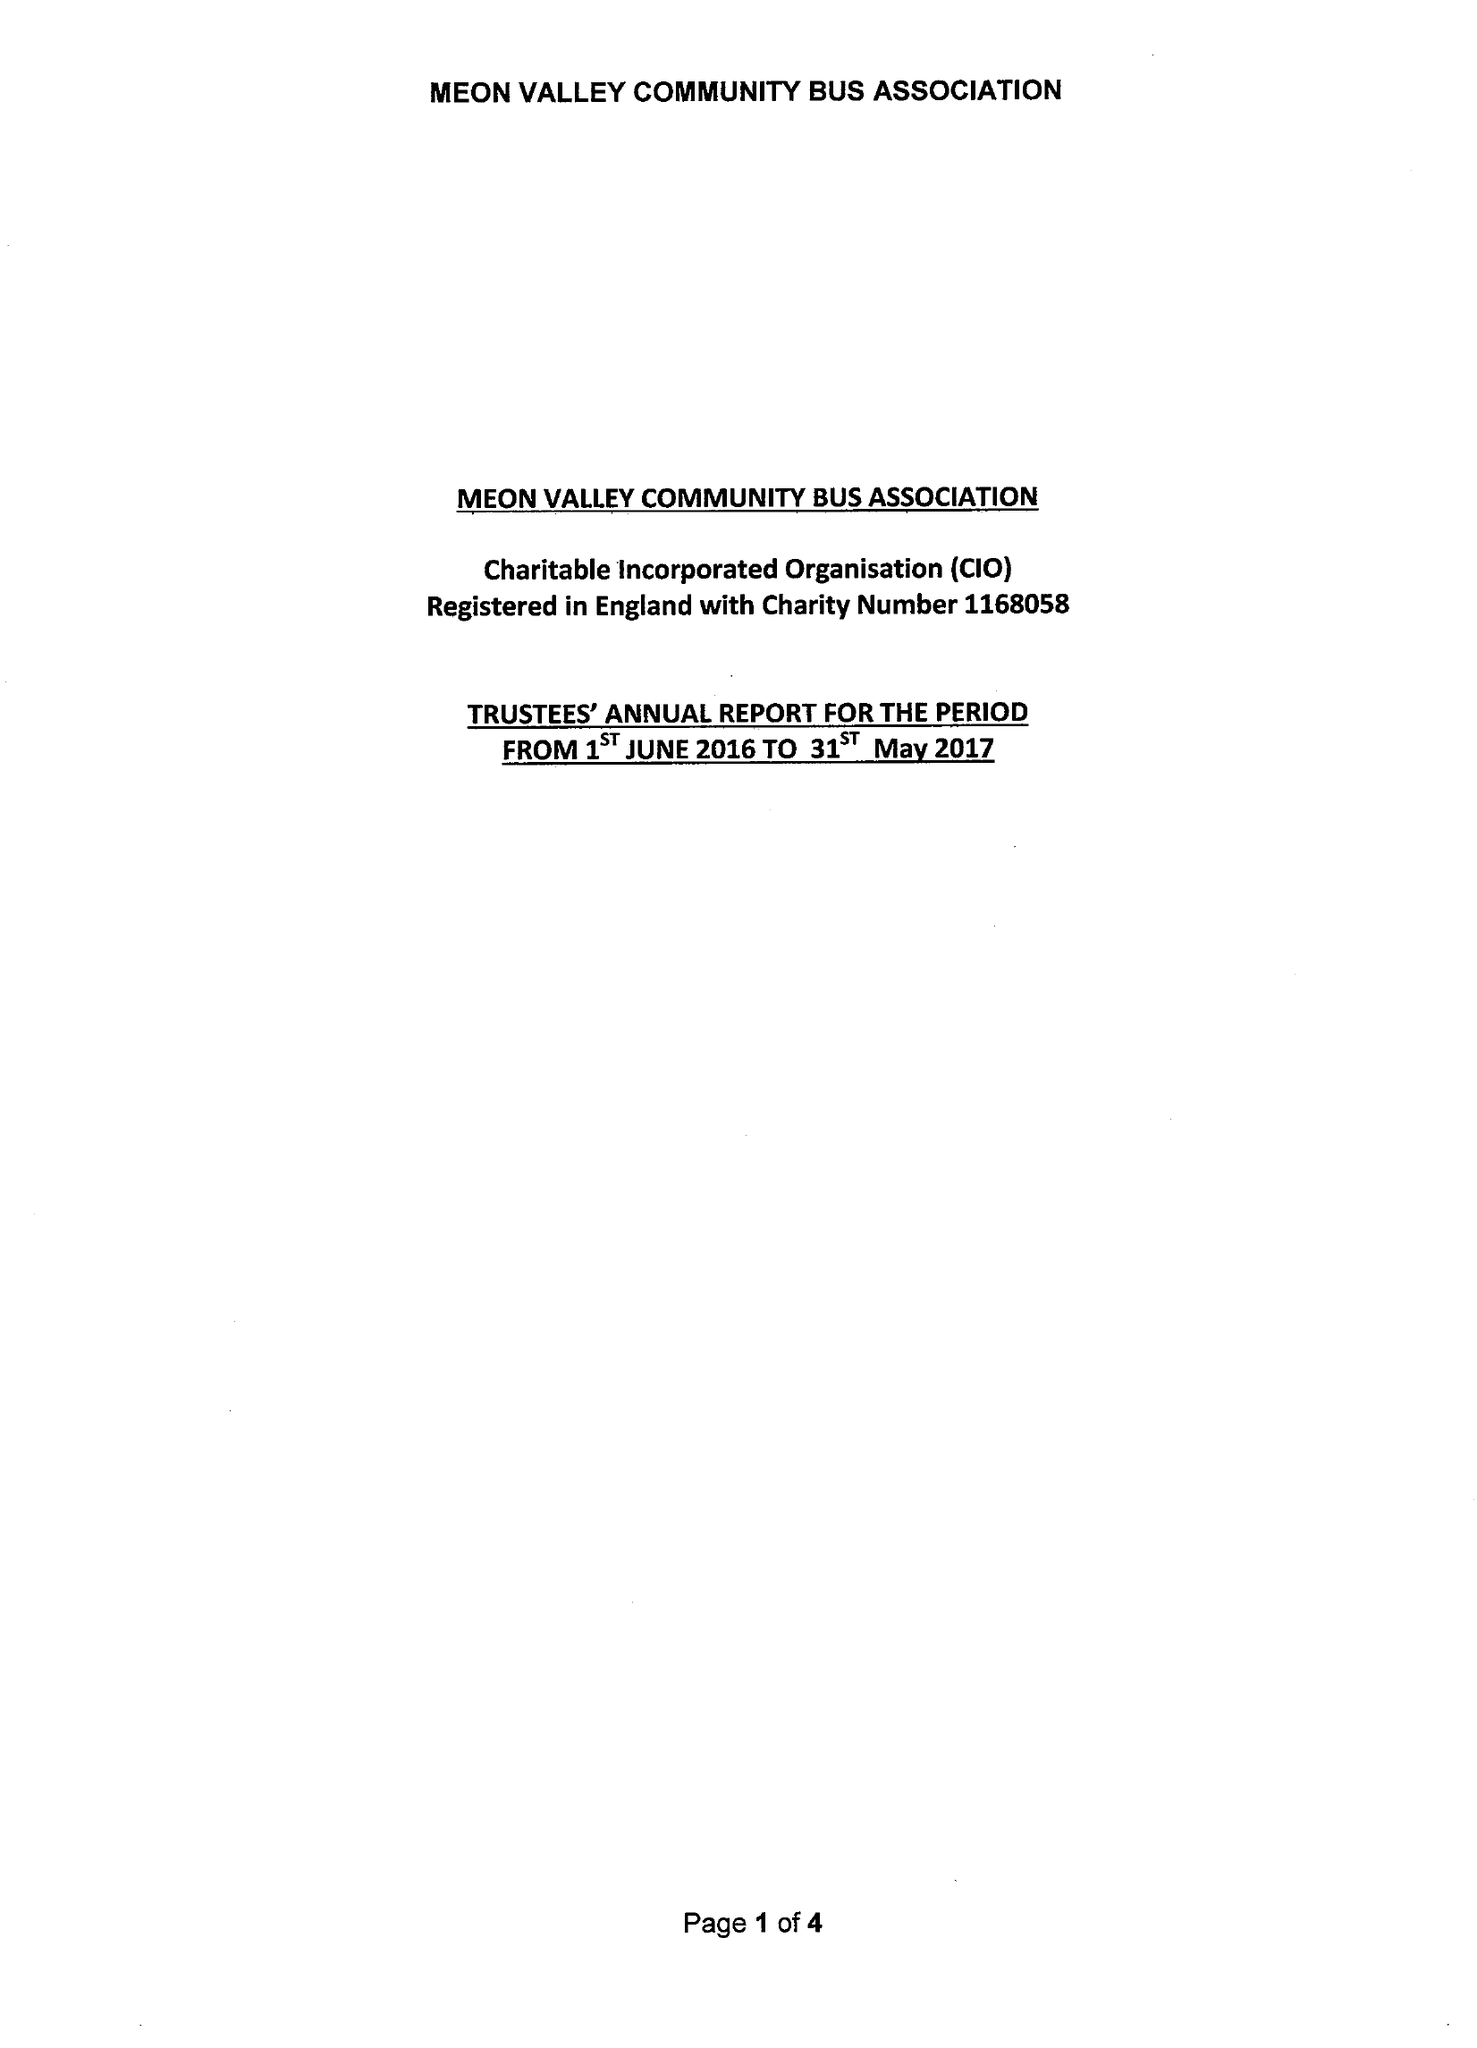What is the value for the spending_annually_in_british_pounds?
Answer the question using a single word or phrase. 34324.00 